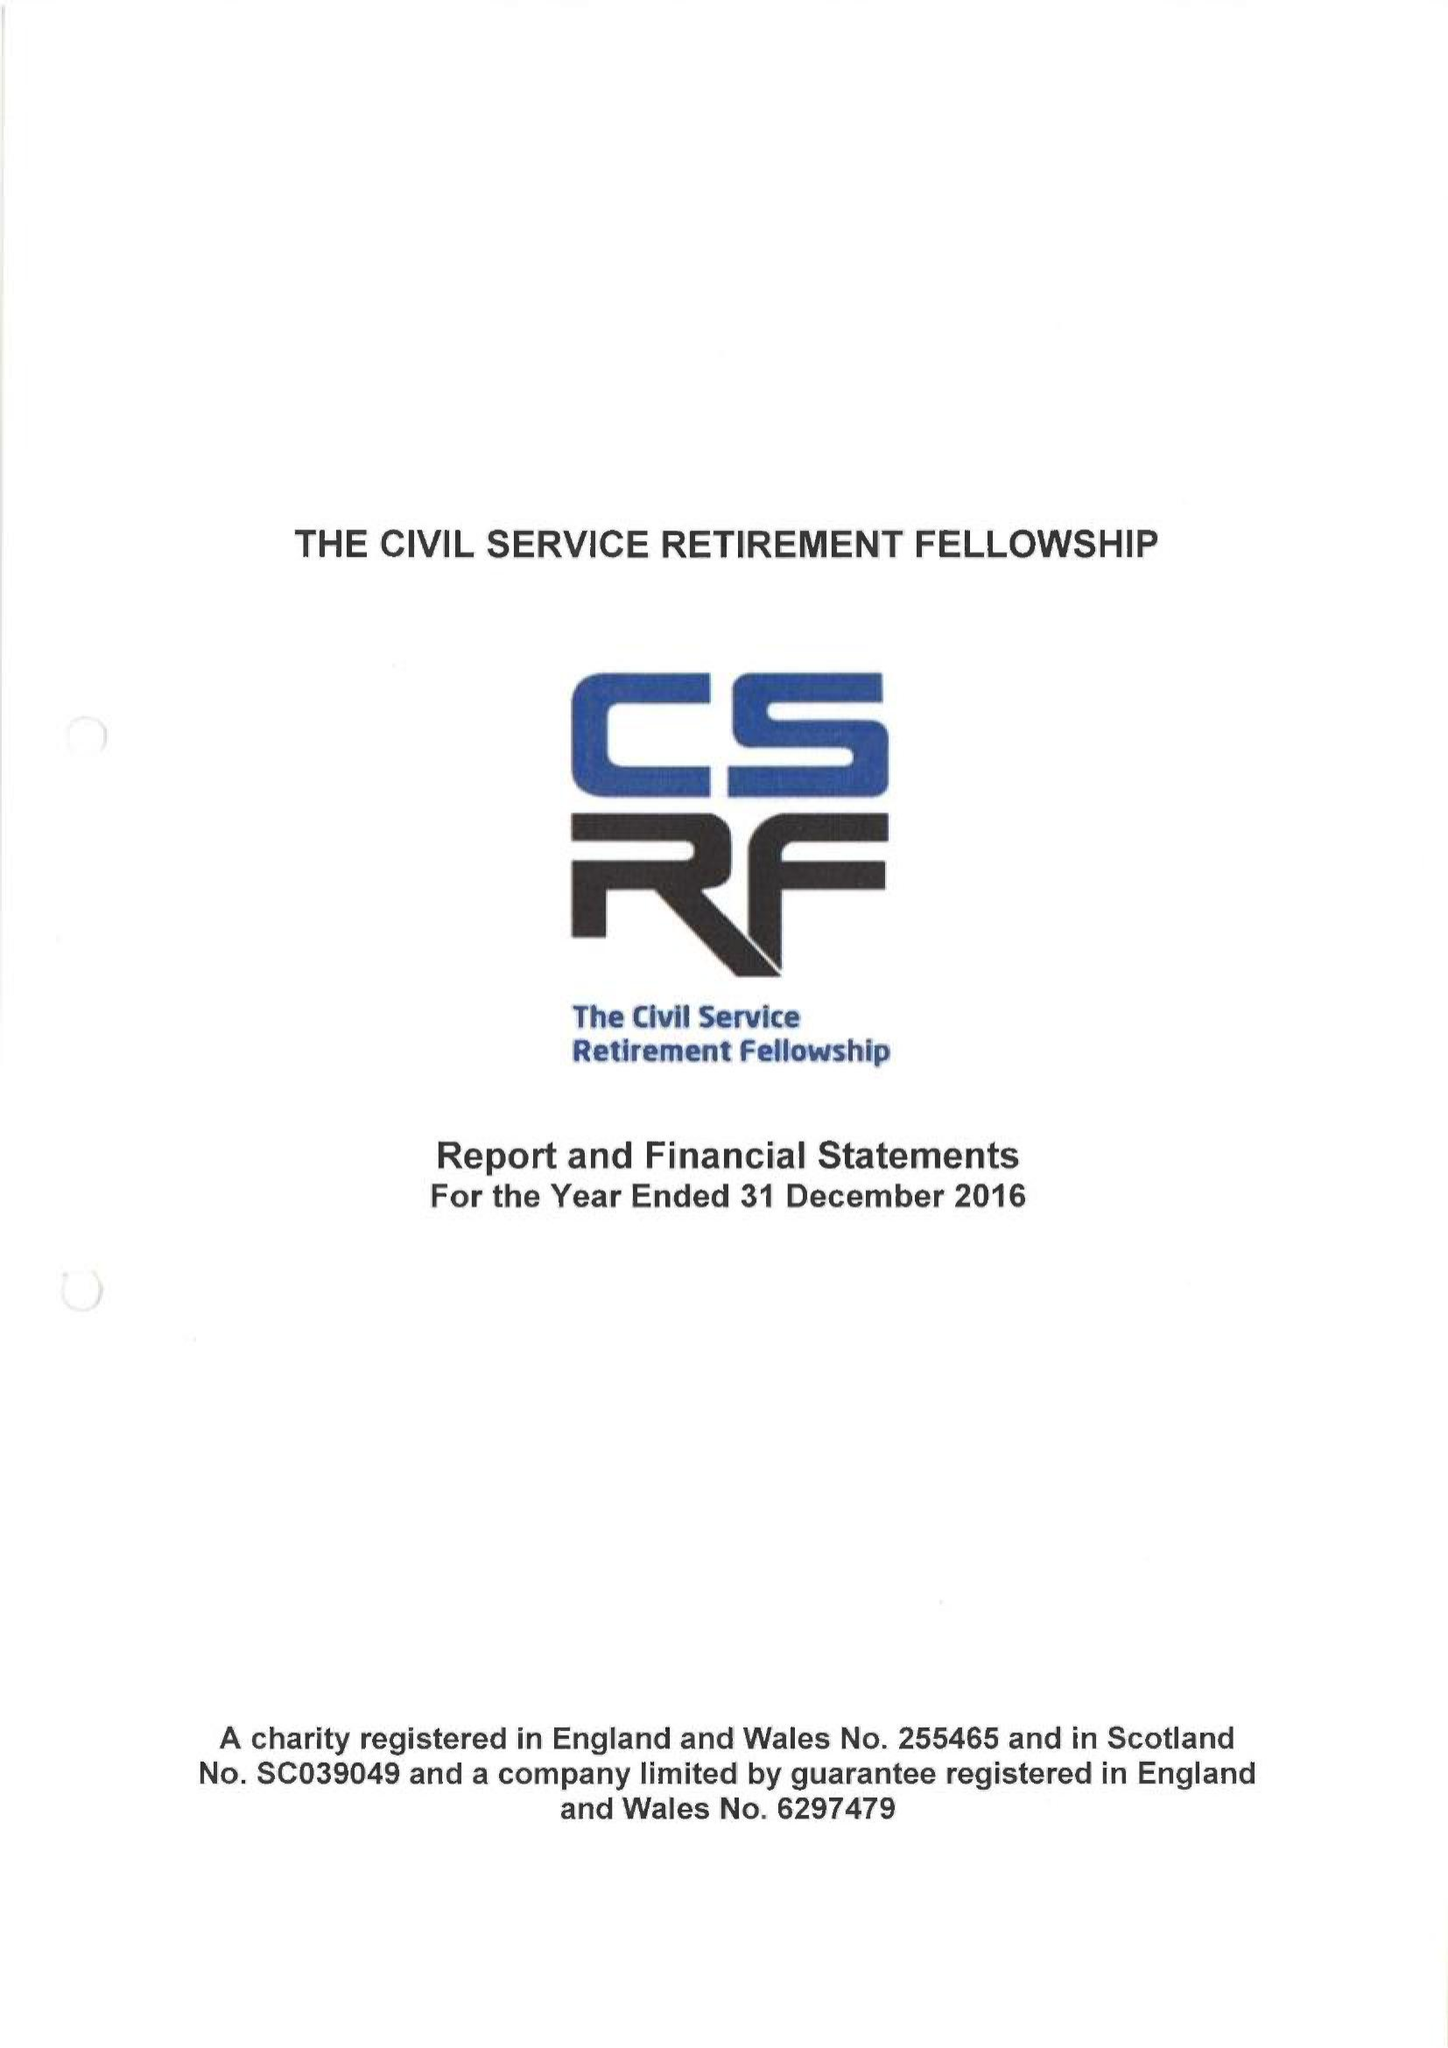What is the value for the address__post_town?
Answer the question using a single word or phrase. LONDON 